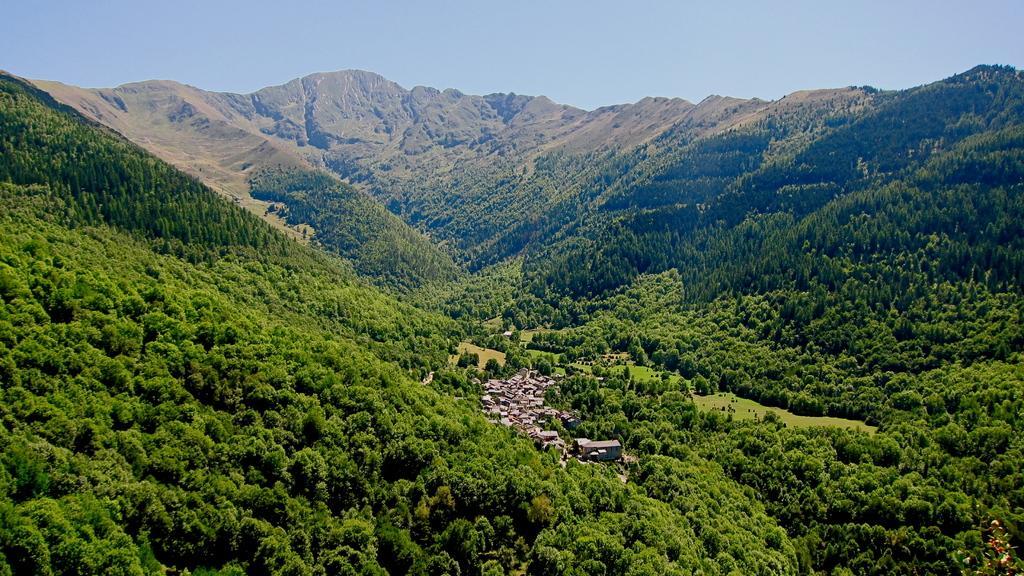Describe this image in one or two sentences. In this picture I can see there are few mountains and there are few buildings here and the mountains are covered with trees and the sky is clear. 